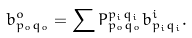<formula> <loc_0><loc_0><loc_500><loc_500>b ^ { o } _ { p _ { o } q _ { o } } = \sum P _ { p _ { o } q _ { o } } ^ { p _ { i } q _ { i } } b ^ { i } _ { p _ { i } q _ { i } } .</formula> 